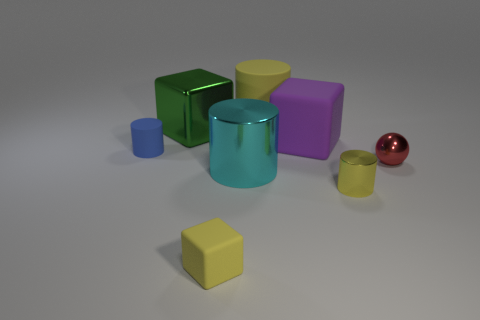Add 1 big cubes. How many objects exist? 9 Subtract all balls. How many objects are left? 7 Add 3 small yellow shiny things. How many small yellow shiny things exist? 4 Subtract 0 blue cubes. How many objects are left? 8 Subtract all tiny yellow metallic cylinders. Subtract all big cylinders. How many objects are left? 5 Add 7 small red metal spheres. How many small red metal spheres are left? 8 